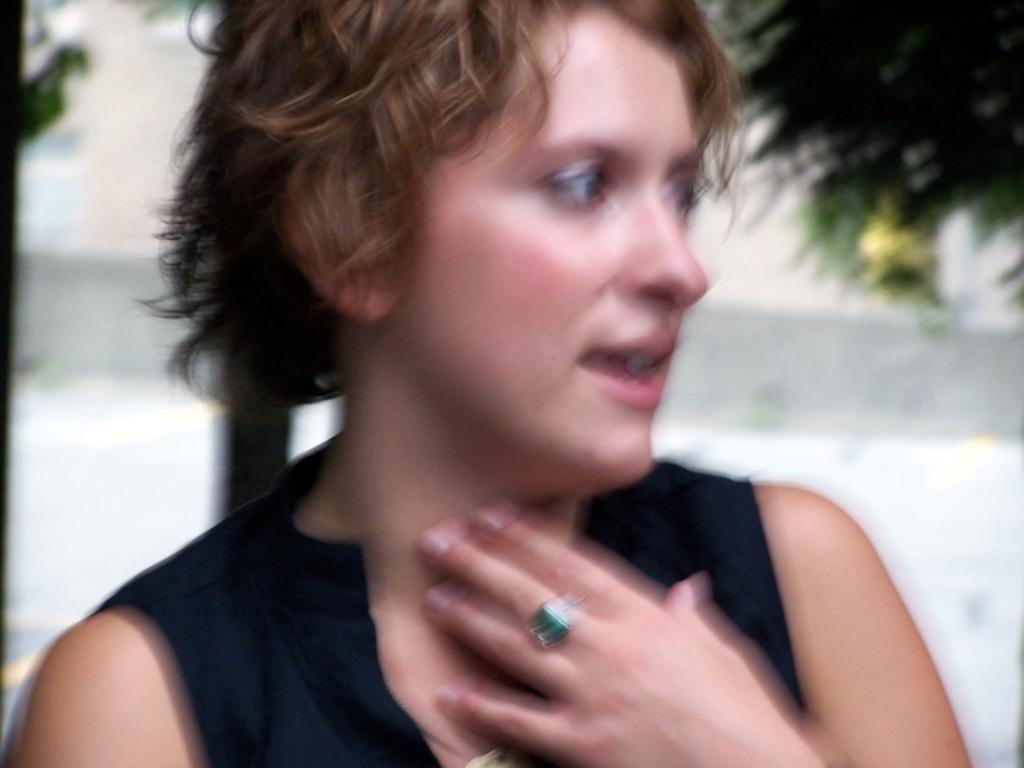What is the main subject in the foreground of the image? There is a woman in the foreground of the image. Can you describe any specific details about the woman or the image? The image is blurry, so the details of the woman or the image may not be clear or accurate. What type of pan can be seen in the woman's hand in the image? There is no pan visible in the image, as the image is blurry and does not show any specific details about the woman or her hand. 